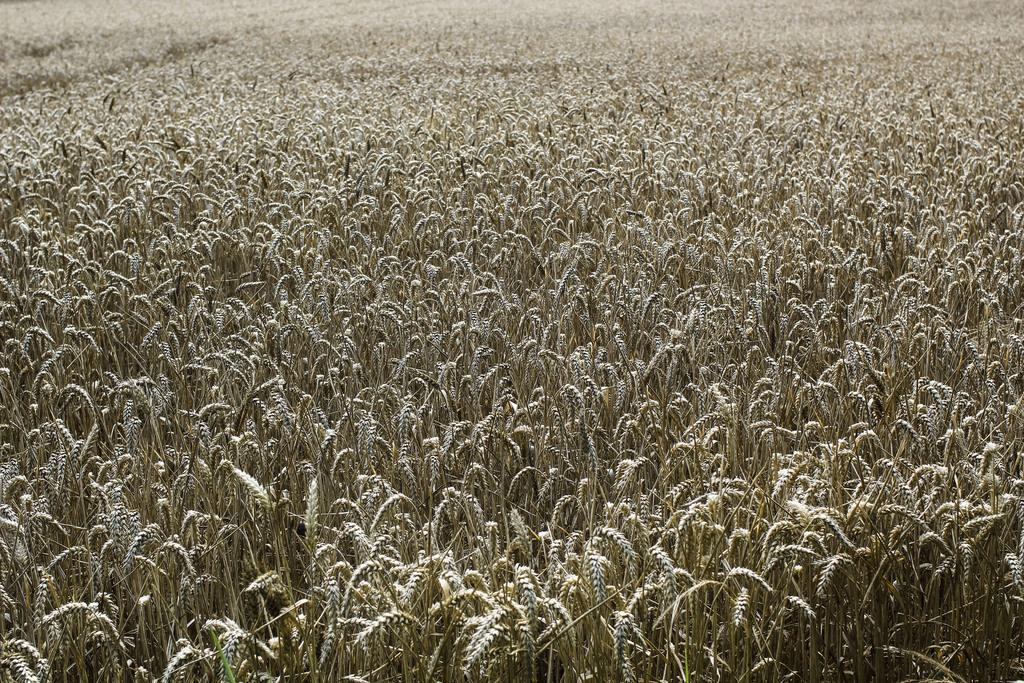What type of living organisms can be seen at the bottom of the image? There are plants at the bottom of the image. What type of ornament can be seen in the cemetery in the image? There is no cemetery or ornament present in the image; it only features plants at the bottom. 